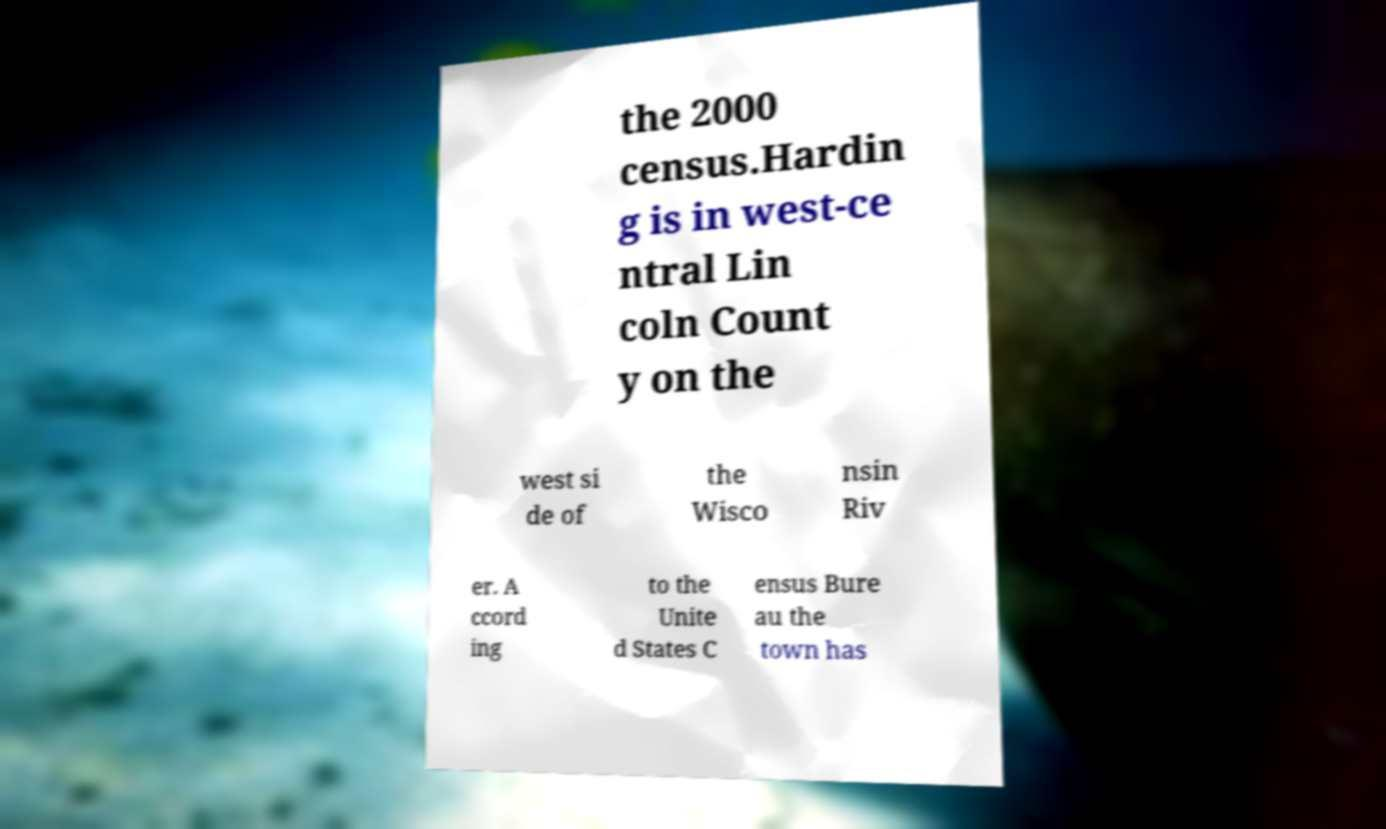There's text embedded in this image that I need extracted. Can you transcribe it verbatim? the 2000 census.Hardin g is in west-ce ntral Lin coln Count y on the west si de of the Wisco nsin Riv er. A ccord ing to the Unite d States C ensus Bure au the town has 